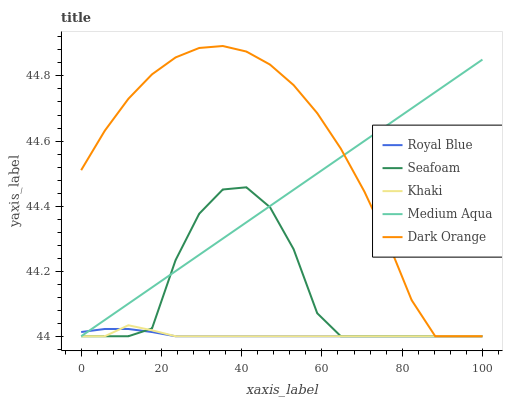Does Khaki have the minimum area under the curve?
Answer yes or no. Yes. Does Dark Orange have the maximum area under the curve?
Answer yes or no. Yes. Does Medium Aqua have the minimum area under the curve?
Answer yes or no. No. Does Medium Aqua have the maximum area under the curve?
Answer yes or no. No. Is Medium Aqua the smoothest?
Answer yes or no. Yes. Is Seafoam the roughest?
Answer yes or no. Yes. Is Khaki the smoothest?
Answer yes or no. No. Is Khaki the roughest?
Answer yes or no. No. Does Khaki have the highest value?
Answer yes or no. No. 